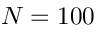Convert formula to latex. <formula><loc_0><loc_0><loc_500><loc_500>N = 1 0 0</formula> 